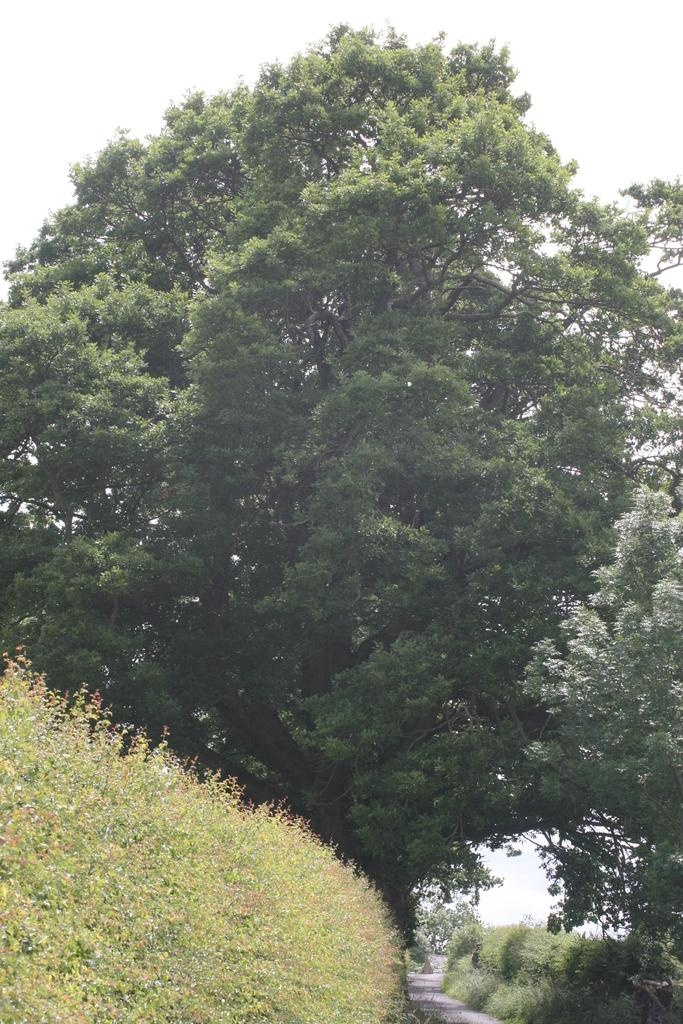What type of vegetation can be seen at the bottom of the image? There are trees at the bottom of the image. What else is present at the bottom of the image? There is a road at the bottom of the image. Are there any trees in other parts of the image? Yes, there are trees in the middle of the image. What is visible at the top of the image? The sky is visible at the top of the image. What type of magic is being performed by the trees in the middle of the image? There is no magic being performed by the trees in the image; they are simply trees. What is the weight of the middle tree in the image? It is not possible to determine the weight of the tree from the image alone. 